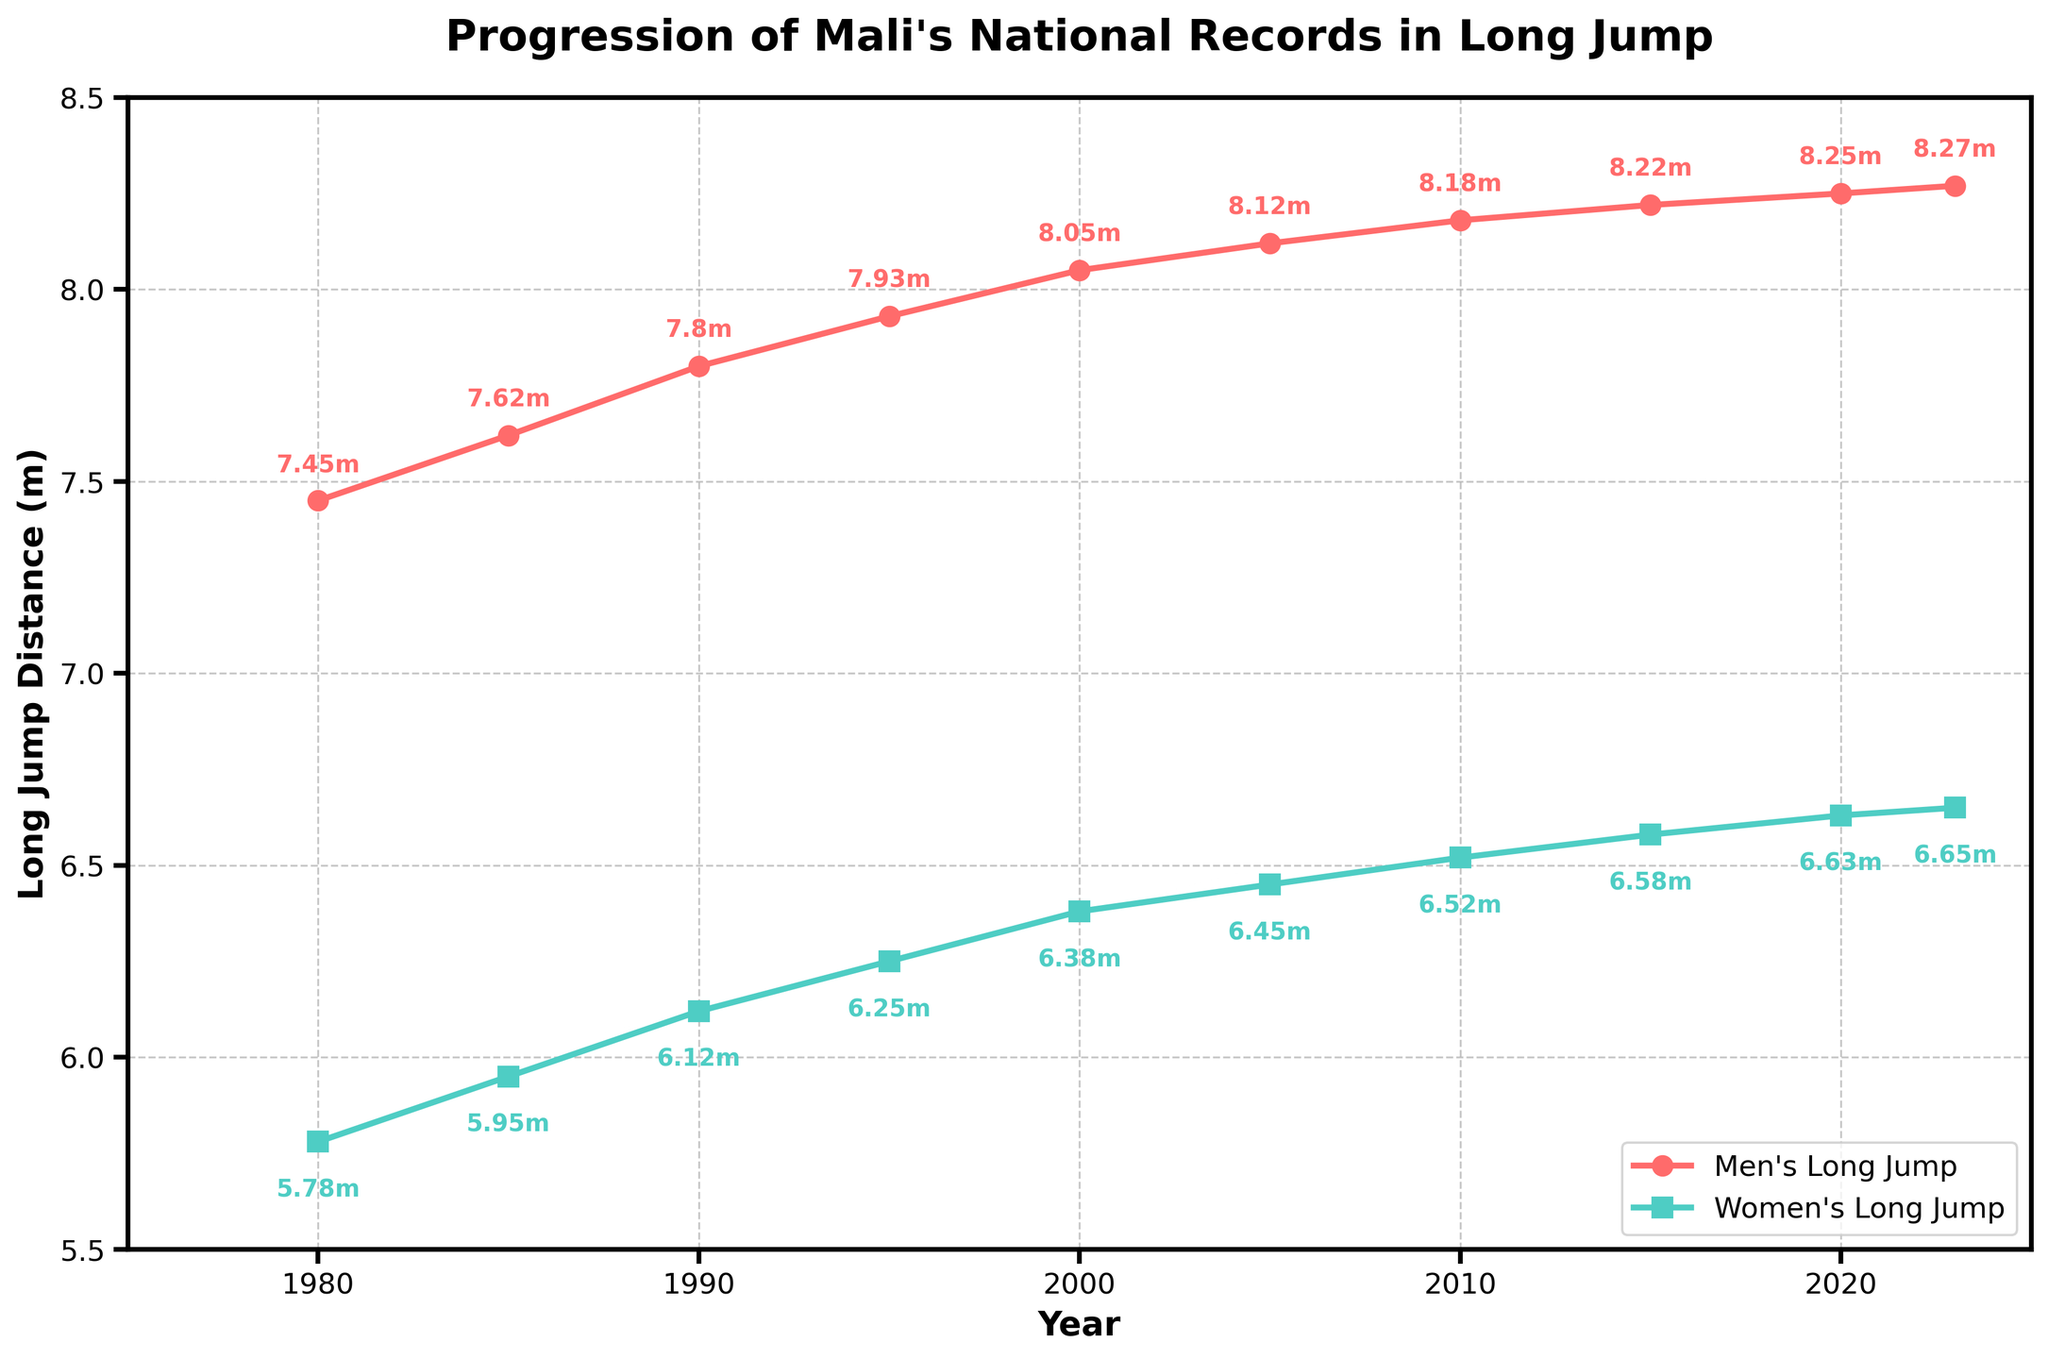What is the pattern of change for Mali's men's long jump records from 1980 to 2023? The men's long jump record shows a consistent upward trend over the years. Starting from 7.45 meters in 1980, it increases steadily in both small and moderate increments, reaching 8.27 meters by 2023.
Answer: Consistent upward trend Which year saw the biggest increase in the men's long jump record? To find the biggest increase, compare the differences between consecutive years. The largest increase is between 1990 and 1995, where the record jumps from 7.80 meters to 7.93 meters.
Answer: 1990 to 1995 Between which two years did the women's long jump record show the smallest increase? By calculating the difference between each consecutive pair of years, the smallest increase appears between 2020 and 2023, moving from 6.63 meters to 6.65 meters, an increase of only 0.02 meters.
Answer: 2020 to 2023 How much did the men's long jump record improve from 1980 to 2023? Subtract the 1980 men's record from the 2023 men's record: 8.27 meters - 7.45 meters = 0.82 meters.
Answer: 0.82 meters Which gender had a larger overall improvement in long jump records from 1980 to 2023? Men's record improved by 0.82 meters (8.27 - 7.45), and women's record improved by 0.87 meters (6.65 - 5.78). Thus, the women's records show a larger overall improvement.
Answer: Women In which year were both the men's and women's long jump records the closest to each other? Identify the year with the smallest difference between men's and women's jump records. In 1980, the difference is the smallest at 1.67 meters (7.45 - 5.78).
Answer: 1980 What is the average men's long jump record over the 43-year period? Add all the men's records and divide by the number of records: (7.45 + 7.62 + 7.80 + 7.93 + 8.05 + 8.12 + 8.18 + 8.22 + 8.25 + 8.27) / 10 = 7.989 meters.
Answer: 7.989 meters How much did the women's long jump record improve between 1990 and 2020? Subtract the 1990 women's record from the 2020 women's record: 6.63 meters - 6.12 meters = 0.51 meters.
Answer: 0.51 meters Which color line represents the women's long jump records in the figure? The women's long jump records are represented by the green line in the chart.
Answer: Green What are the men's and women's long jump records in the year 2000? From the year 2000 data points, the men's long jump record is 8.05 meters, and the women's long jump record is 6.38 meters.
Answer: 8.05 meters (men), 6.38 meters (women) 